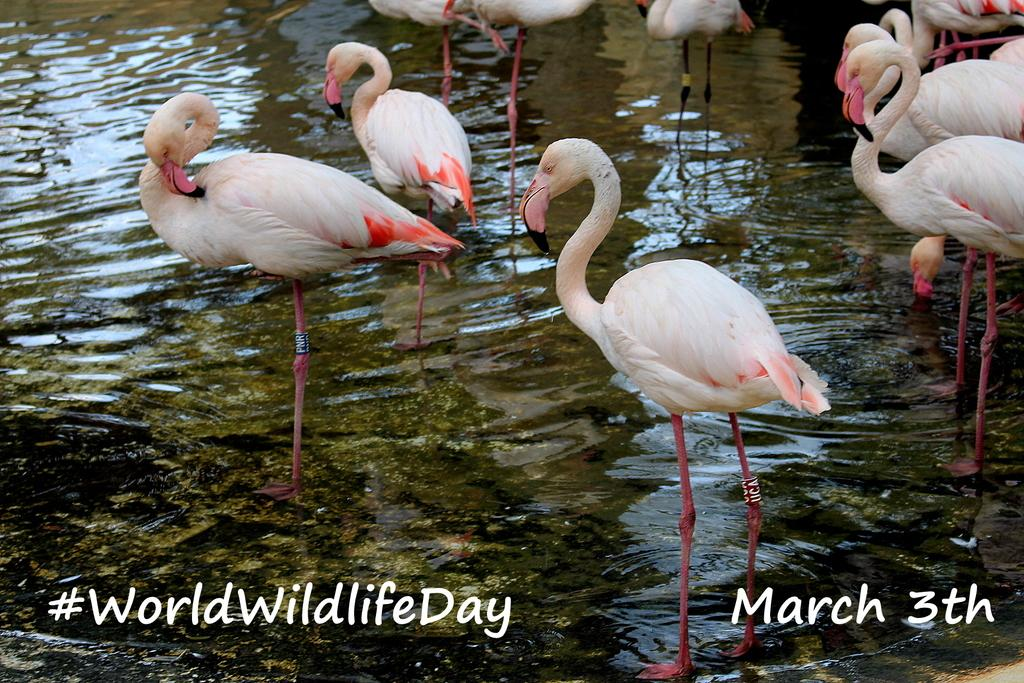What type of animals are present in the image? There are flamingo birds in the image. What are the flamingo birds doing in the image? The flamingo birds are standing. What is at the bottom of the image? There is water at the bottom of the image. Is there any text visible in the image? Yes, there is some text visible in the image. How does the stranger transport the flamingo birds in the image? There is no stranger present in the image, and the flamingo birds are standing, not being transported. 